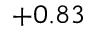<formula> <loc_0><loc_0><loc_500><loc_500>+ 0 . 8 3</formula> 